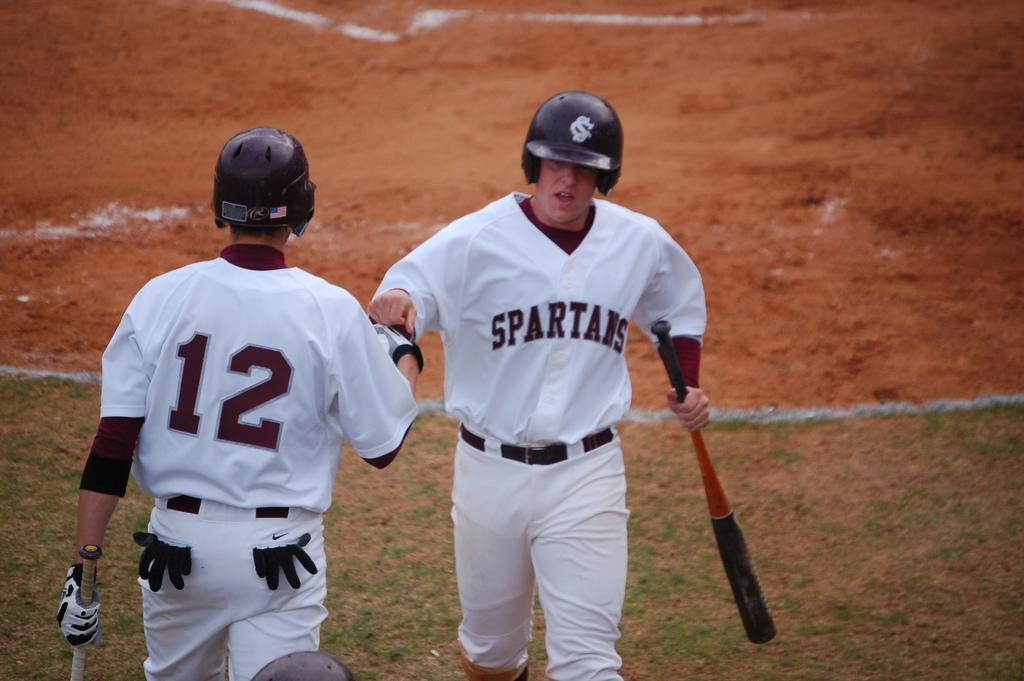How many people are in the image? There are two men in the image. What are the men holding in their hands? The men are holding baseball bats. What are the men doing in the image? The men are walking. What is the setting of the image? The setting appears to be a ground or field. What color is the eye of the man on the left? There is no eye visible in the image, as the men are not facing the camera. 